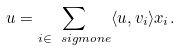Convert formula to latex. <formula><loc_0><loc_0><loc_500><loc_500>u = \sum _ { i \in \ s i g m o n e } \langle u , v _ { i } \rangle x _ { i } .</formula> 